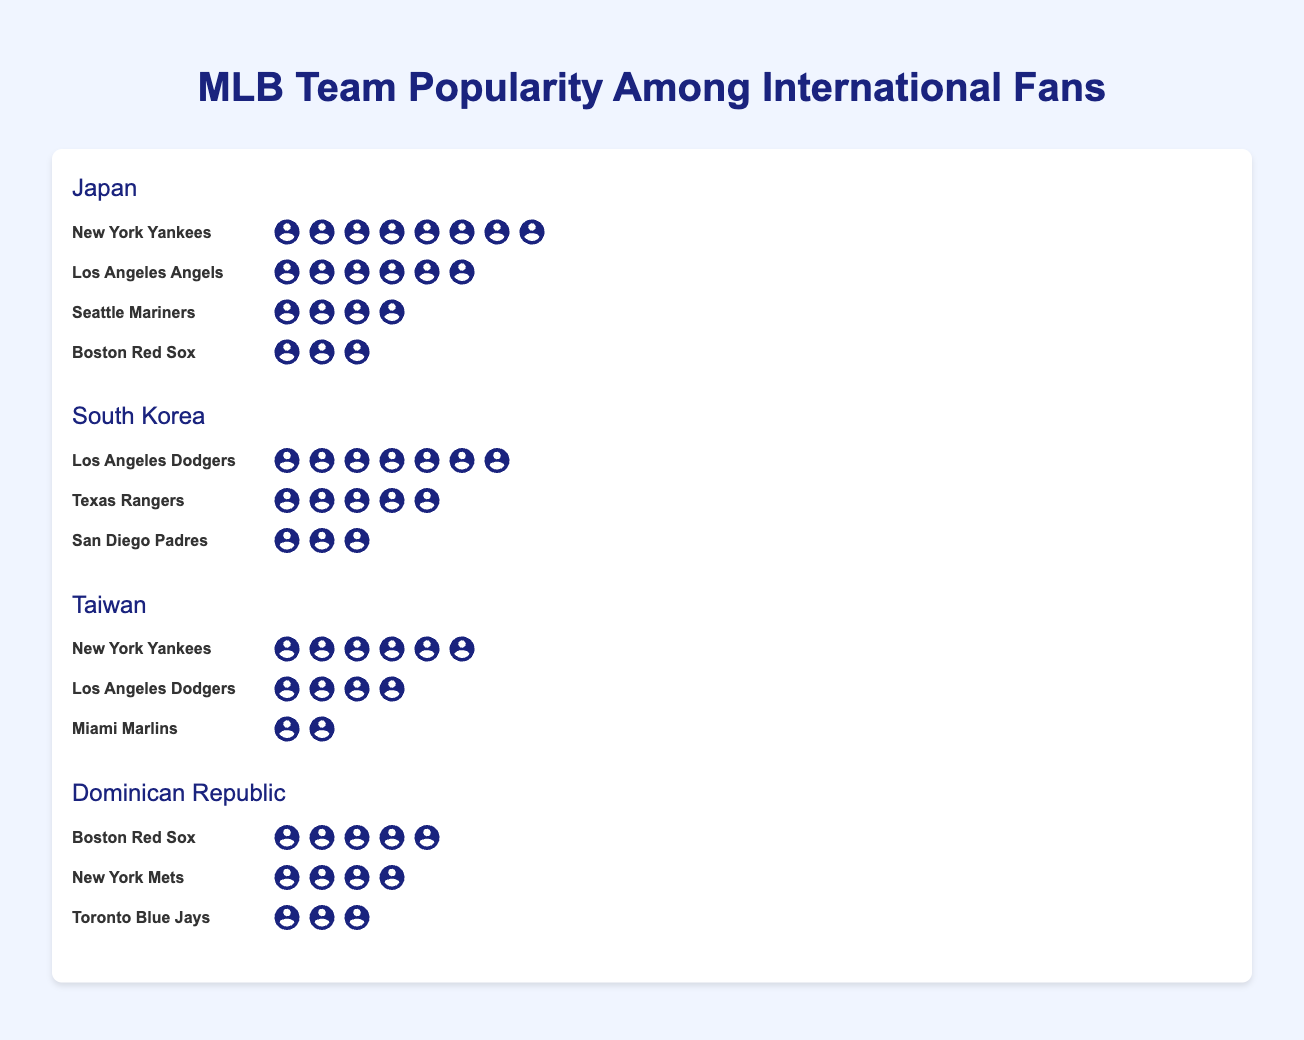How many fans of the New York Yankees are there in Japan? Look for the New York Yankees under the country Japan, and count the number of fan icons next to it.
Answer: 8 Out of all the teams listed for South Korea, which team has the fewest fans? Locate South Korea, then compare the number of fan icons of the listed teams: Los Angeles Dodgers, Texas Rangers, and San Diego Padres.
Answer: San Diego Padres Which country has the highest number of Los Angeles Dodgers fans? Identify the number of Los Angeles Dodgers fans in each country and compare them. South Korea has 7, and Taiwan has 4.
Answer: South Korea How many more fans do the New York Yankees have in Japan compared to Taiwan? Find the number of fans for the New York Yankees in Japan and Taiwan, then subtract the smaller value from the larger one. 8 in Japan minus 6 in Taiwan equals 2.
Answer: 2 What is the total number of baseball fans in Taiwan according to the chart? Sum the number of fans for all the teams listed under Taiwan: New York Yankees (6), Los Angeles Dodgers (4), and Miami Marlins (2).
Answer: 12 How many teams listed in the chart have more than 5 fans across all countries? Identify which teams have more than 5 fans in any country in the figure: New York Yankees (8 in Japan, 6 in Taiwan), Los Angeles Dodgers (7 in South Korea), and Boston Red Sox (5 in the Dominican Republic, 3 in Japan).
Answer: 3 Which country has the second most fans of the Boston Red Sox? Look at all the countries and find the number of fans for the Boston Red Sox. Japan has 3 and the Dominican Republic has 5. Japan has the second most.
Answer: Japan In which country do the New York Mets have more fans than the Toronto Blue Jays? Compare the number of fans of the New York Mets and the Toronto Blue Jays under the Dominican Republic. The New York Mets have 4 fans, while the Toronto Blue Jays have 3, making the New York Mets fans more.
Answer: Dominican Republic 